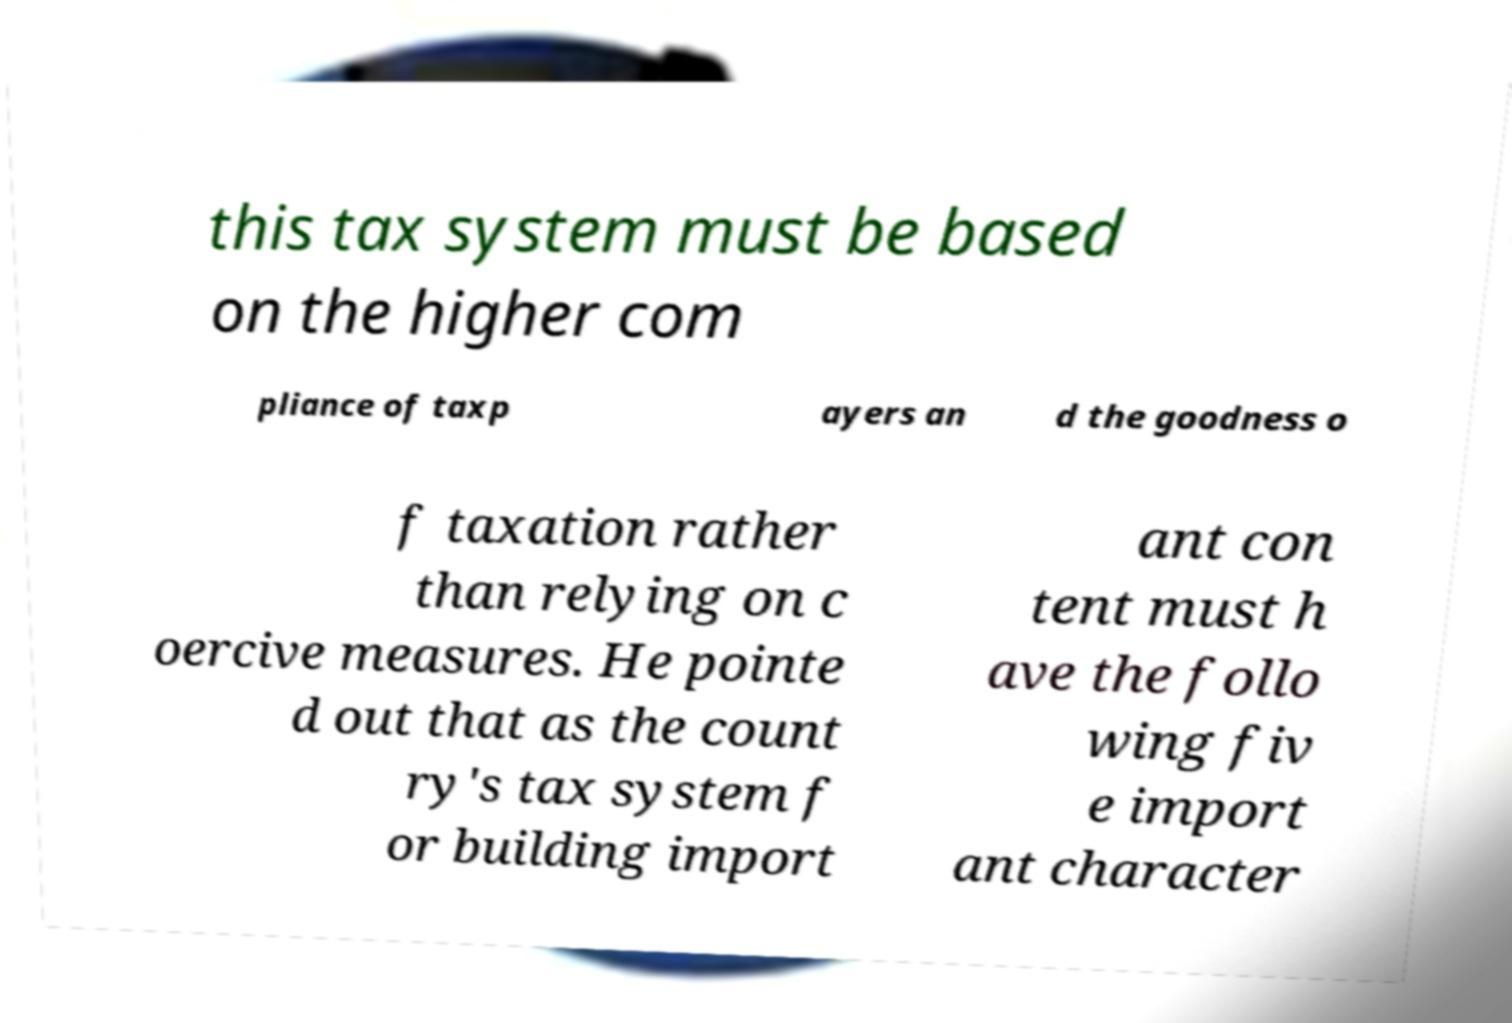Can you accurately transcribe the text from the provided image for me? this tax system must be based on the higher com pliance of taxp ayers an d the goodness o f taxation rather than relying on c oercive measures. He pointe d out that as the count ry's tax system f or building import ant con tent must h ave the follo wing fiv e import ant character 